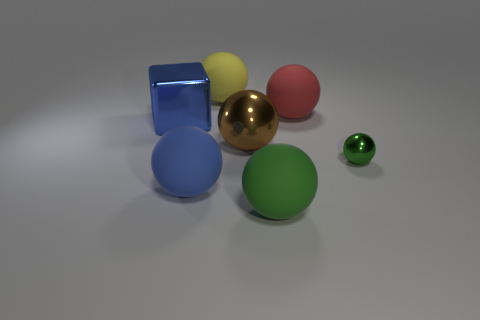Is the number of big yellow balls that are behind the blue metallic thing the same as the number of large purple balls?
Your response must be concise. No. There is a thing that is the same color as the big cube; what size is it?
Your answer should be very brief. Large. Are there any blue balls that have the same material as the big yellow thing?
Your answer should be compact. Yes. There is a thing in front of the blue matte ball; does it have the same shape as the large object behind the big red rubber thing?
Provide a short and direct response. Yes. Are any small green spheres visible?
Provide a succinct answer. Yes. What color is the metal sphere that is the same size as the yellow rubber thing?
Your answer should be very brief. Brown. How many other tiny blue things are the same shape as the small shiny thing?
Offer a very short reply. 0. Do the ball that is to the left of the yellow matte sphere and the large brown ball have the same material?
Your response must be concise. No. How many cubes are either large blue objects or big yellow rubber objects?
Your answer should be compact. 1. The object in front of the large rubber thing to the left of the thing that is behind the big red sphere is what shape?
Your answer should be very brief. Sphere. 